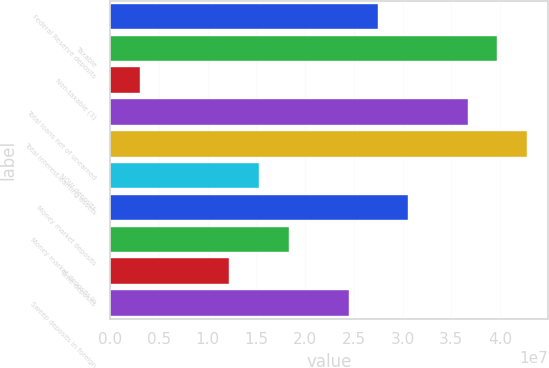Convert chart. <chart><loc_0><loc_0><loc_500><loc_500><bar_chart><fcel>Federal Reserve deposits<fcel>Taxable<fcel>Non-taxable (3)<fcel>Total loans net of unearned<fcel>Total interest-earning assets<fcel>NOW deposits<fcel>Money market deposits<fcel>Money market deposits in<fcel>Time deposits<fcel>Sweep deposits in foreign<nl><fcel>2.7515e+07<fcel>3.97411e+07<fcel>3.06279e+06<fcel>3.66846e+07<fcel>4.27976e+07<fcel>1.52889e+07<fcel>3.05715e+07<fcel>1.83454e+07<fcel>1.22324e+07<fcel>2.44585e+07<nl></chart> 